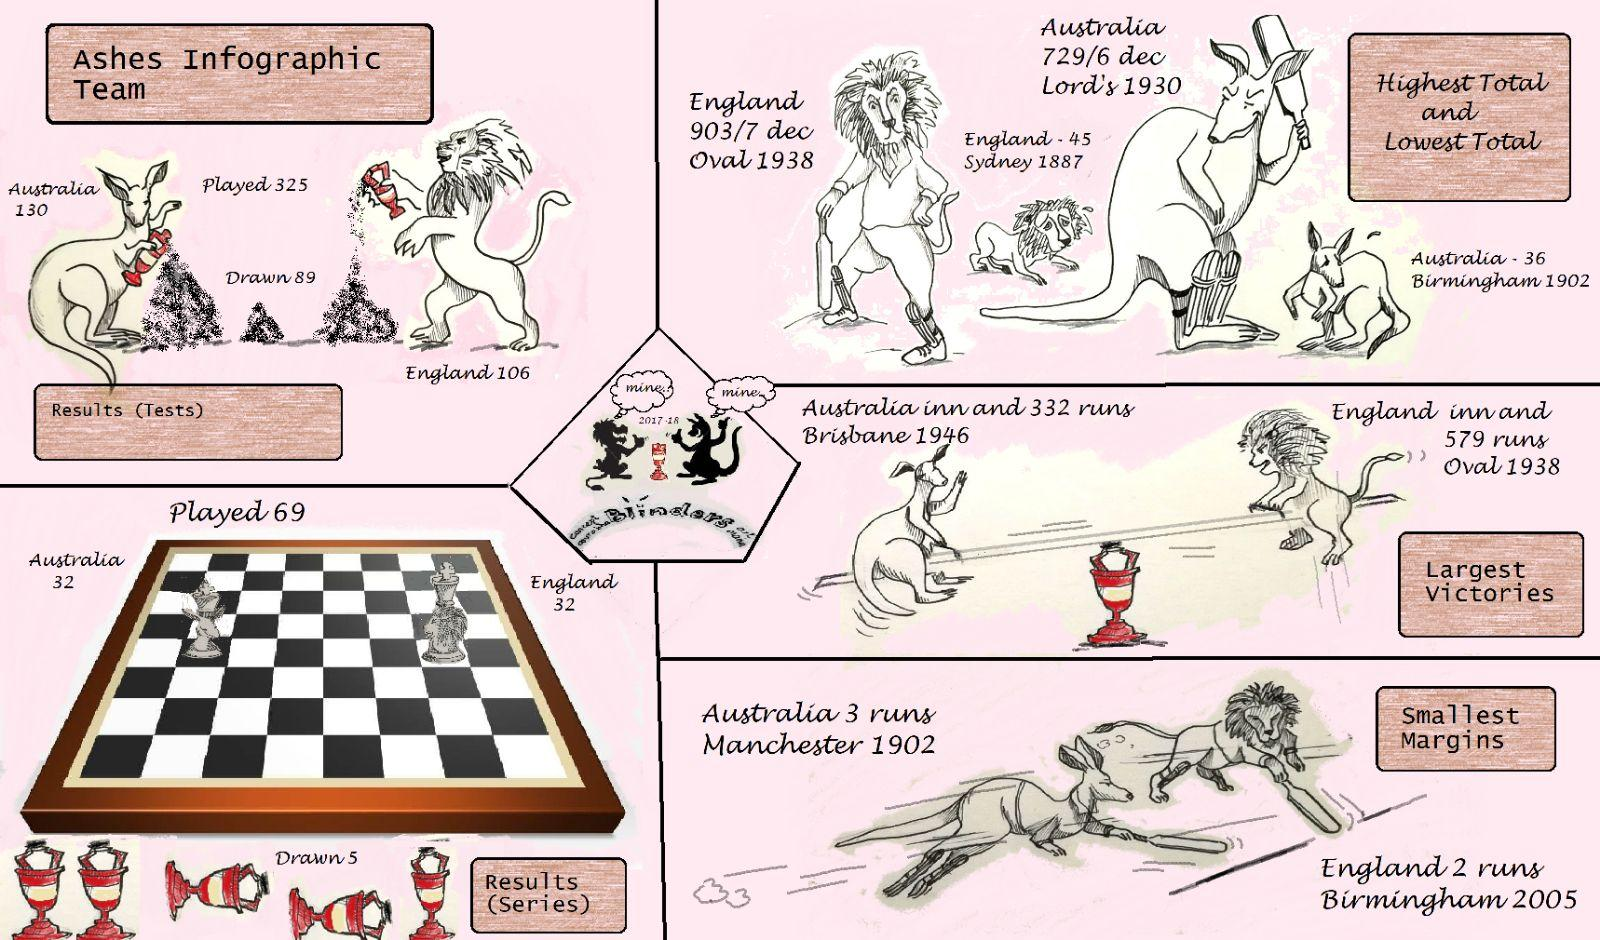Indicate a few pertinent items in this graphic. Australia won a total of 130 matches. In the year 1938, the highest total was scored. 